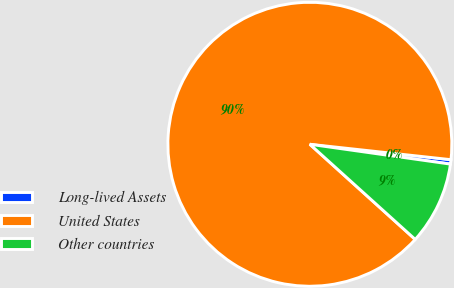<chart> <loc_0><loc_0><loc_500><loc_500><pie_chart><fcel>Long-lived Assets<fcel>United States<fcel>Other countries<nl><fcel>0.5%<fcel>90.04%<fcel>9.46%<nl></chart> 